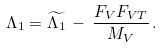Convert formula to latex. <formula><loc_0><loc_0><loc_500><loc_500>\Lambda _ { 1 } = \widetilde { \Lambda _ { 1 } } \, - \, \frac { F _ { V } F _ { V T } } { M _ { V } } \, .</formula> 